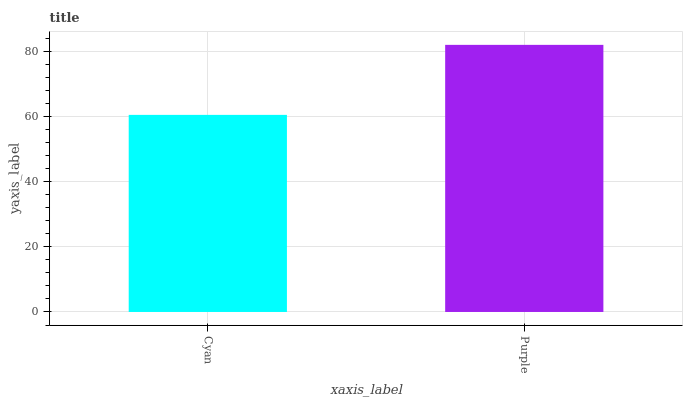Is Cyan the minimum?
Answer yes or no. Yes. Is Purple the maximum?
Answer yes or no. Yes. Is Purple the minimum?
Answer yes or no. No. Is Purple greater than Cyan?
Answer yes or no. Yes. Is Cyan less than Purple?
Answer yes or no. Yes. Is Cyan greater than Purple?
Answer yes or no. No. Is Purple less than Cyan?
Answer yes or no. No. Is Purple the high median?
Answer yes or no. Yes. Is Cyan the low median?
Answer yes or no. Yes. Is Cyan the high median?
Answer yes or no. No. Is Purple the low median?
Answer yes or no. No. 